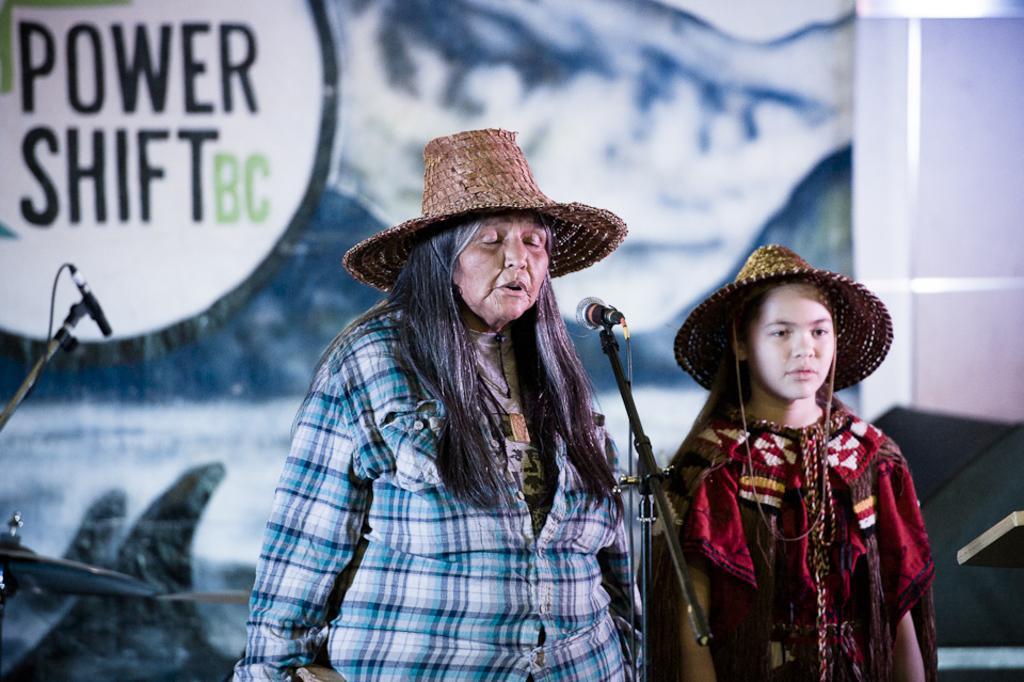Describe this image in one or two sentences. In this image there are persons standing and in the front there is a mic. In the background there is a banner with some text written on it and there is a mic stand. 